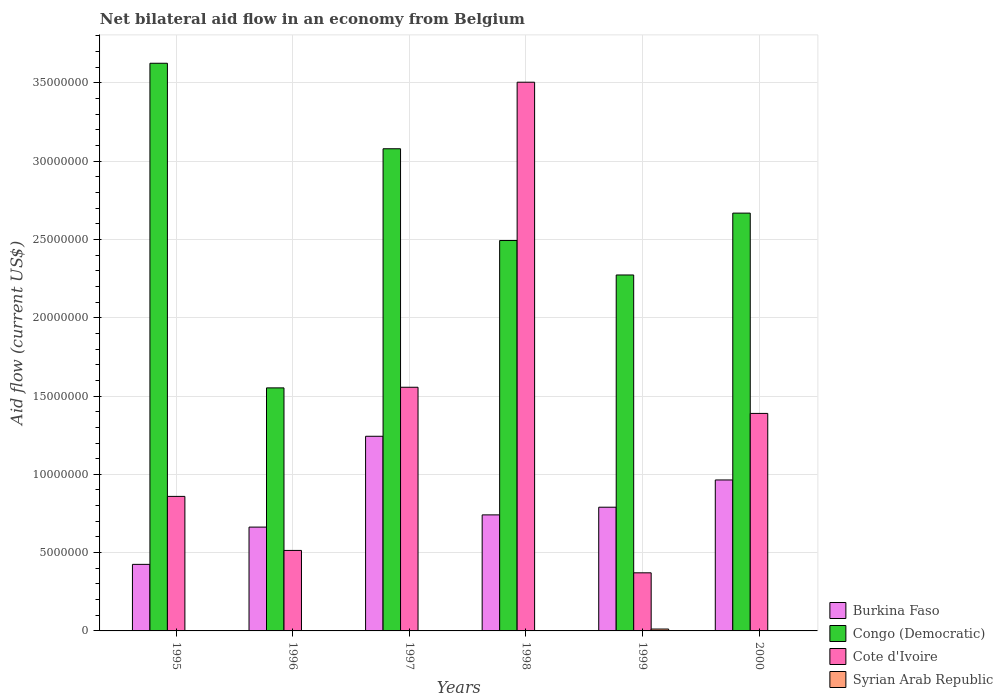How many different coloured bars are there?
Your answer should be compact. 4. How many groups of bars are there?
Provide a succinct answer. 6. Are the number of bars on each tick of the X-axis equal?
Offer a terse response. No. How many bars are there on the 2nd tick from the left?
Provide a succinct answer. 3. How many bars are there on the 1st tick from the right?
Keep it short and to the point. 3. What is the label of the 2nd group of bars from the left?
Keep it short and to the point. 1996. What is the net bilateral aid flow in Congo (Democratic) in 2000?
Provide a short and direct response. 2.67e+07. Across all years, what is the maximum net bilateral aid flow in Burkina Faso?
Give a very brief answer. 1.24e+07. Across all years, what is the minimum net bilateral aid flow in Congo (Democratic)?
Keep it short and to the point. 1.55e+07. What is the difference between the net bilateral aid flow in Burkina Faso in 1997 and that in 1999?
Give a very brief answer. 4.53e+06. What is the difference between the net bilateral aid flow in Burkina Faso in 2000 and the net bilateral aid flow in Syrian Arab Republic in 1997?
Provide a short and direct response. 9.64e+06. What is the average net bilateral aid flow in Syrian Arab Republic per year?
Give a very brief answer. 2.00e+04. In the year 1999, what is the difference between the net bilateral aid flow in Syrian Arab Republic and net bilateral aid flow in Congo (Democratic)?
Your response must be concise. -2.26e+07. What is the ratio of the net bilateral aid flow in Congo (Democratic) in 1996 to that in 1997?
Provide a short and direct response. 0.5. What is the difference between the highest and the second highest net bilateral aid flow in Burkina Faso?
Give a very brief answer. 2.79e+06. What is the difference between the highest and the lowest net bilateral aid flow in Burkina Faso?
Keep it short and to the point. 8.18e+06. In how many years, is the net bilateral aid flow in Burkina Faso greater than the average net bilateral aid flow in Burkina Faso taken over all years?
Your response must be concise. 2. Is it the case that in every year, the sum of the net bilateral aid flow in Burkina Faso and net bilateral aid flow in Congo (Democratic) is greater than the net bilateral aid flow in Syrian Arab Republic?
Ensure brevity in your answer.  Yes. How many bars are there?
Offer a terse response. 19. Are all the bars in the graph horizontal?
Your response must be concise. No. How many years are there in the graph?
Ensure brevity in your answer.  6. What is the difference between two consecutive major ticks on the Y-axis?
Provide a succinct answer. 5.00e+06. How many legend labels are there?
Your response must be concise. 4. How are the legend labels stacked?
Your answer should be very brief. Vertical. What is the title of the graph?
Ensure brevity in your answer.  Net bilateral aid flow in an economy from Belgium. Does "Costa Rica" appear as one of the legend labels in the graph?
Provide a short and direct response. No. What is the label or title of the X-axis?
Ensure brevity in your answer.  Years. What is the label or title of the Y-axis?
Your answer should be very brief. Aid flow (current US$). What is the Aid flow (current US$) in Burkina Faso in 1995?
Offer a terse response. 4.25e+06. What is the Aid flow (current US$) in Congo (Democratic) in 1995?
Your answer should be compact. 3.62e+07. What is the Aid flow (current US$) of Cote d'Ivoire in 1995?
Keep it short and to the point. 8.59e+06. What is the Aid flow (current US$) in Burkina Faso in 1996?
Ensure brevity in your answer.  6.63e+06. What is the Aid flow (current US$) of Congo (Democratic) in 1996?
Your answer should be very brief. 1.55e+07. What is the Aid flow (current US$) of Cote d'Ivoire in 1996?
Ensure brevity in your answer.  5.14e+06. What is the Aid flow (current US$) of Syrian Arab Republic in 1996?
Ensure brevity in your answer.  0. What is the Aid flow (current US$) in Burkina Faso in 1997?
Ensure brevity in your answer.  1.24e+07. What is the Aid flow (current US$) in Congo (Democratic) in 1997?
Your response must be concise. 3.08e+07. What is the Aid flow (current US$) in Cote d'Ivoire in 1997?
Provide a succinct answer. 1.56e+07. What is the Aid flow (current US$) of Burkina Faso in 1998?
Provide a succinct answer. 7.41e+06. What is the Aid flow (current US$) of Congo (Democratic) in 1998?
Give a very brief answer. 2.49e+07. What is the Aid flow (current US$) in Cote d'Ivoire in 1998?
Ensure brevity in your answer.  3.50e+07. What is the Aid flow (current US$) in Burkina Faso in 1999?
Offer a very short reply. 7.90e+06. What is the Aid flow (current US$) of Congo (Democratic) in 1999?
Offer a very short reply. 2.27e+07. What is the Aid flow (current US$) in Cote d'Ivoire in 1999?
Your response must be concise. 3.71e+06. What is the Aid flow (current US$) in Syrian Arab Republic in 1999?
Your answer should be compact. 1.20e+05. What is the Aid flow (current US$) of Burkina Faso in 2000?
Your answer should be compact. 9.64e+06. What is the Aid flow (current US$) in Congo (Democratic) in 2000?
Ensure brevity in your answer.  2.67e+07. What is the Aid flow (current US$) in Cote d'Ivoire in 2000?
Your response must be concise. 1.39e+07. What is the Aid flow (current US$) in Syrian Arab Republic in 2000?
Your response must be concise. 0. Across all years, what is the maximum Aid flow (current US$) in Burkina Faso?
Provide a short and direct response. 1.24e+07. Across all years, what is the maximum Aid flow (current US$) of Congo (Democratic)?
Offer a terse response. 3.62e+07. Across all years, what is the maximum Aid flow (current US$) of Cote d'Ivoire?
Give a very brief answer. 3.50e+07. Across all years, what is the minimum Aid flow (current US$) of Burkina Faso?
Your response must be concise. 4.25e+06. Across all years, what is the minimum Aid flow (current US$) in Congo (Democratic)?
Provide a succinct answer. 1.55e+07. Across all years, what is the minimum Aid flow (current US$) of Cote d'Ivoire?
Keep it short and to the point. 3.71e+06. What is the total Aid flow (current US$) of Burkina Faso in the graph?
Provide a short and direct response. 4.83e+07. What is the total Aid flow (current US$) in Congo (Democratic) in the graph?
Provide a succinct answer. 1.57e+08. What is the total Aid flow (current US$) in Cote d'Ivoire in the graph?
Your answer should be very brief. 8.19e+07. What is the difference between the Aid flow (current US$) in Burkina Faso in 1995 and that in 1996?
Your answer should be very brief. -2.38e+06. What is the difference between the Aid flow (current US$) in Congo (Democratic) in 1995 and that in 1996?
Keep it short and to the point. 2.07e+07. What is the difference between the Aid flow (current US$) in Cote d'Ivoire in 1995 and that in 1996?
Your answer should be compact. 3.45e+06. What is the difference between the Aid flow (current US$) of Burkina Faso in 1995 and that in 1997?
Ensure brevity in your answer.  -8.18e+06. What is the difference between the Aid flow (current US$) in Congo (Democratic) in 1995 and that in 1997?
Provide a succinct answer. 5.46e+06. What is the difference between the Aid flow (current US$) in Cote d'Ivoire in 1995 and that in 1997?
Provide a succinct answer. -6.97e+06. What is the difference between the Aid flow (current US$) in Burkina Faso in 1995 and that in 1998?
Provide a short and direct response. -3.16e+06. What is the difference between the Aid flow (current US$) in Congo (Democratic) in 1995 and that in 1998?
Your response must be concise. 1.13e+07. What is the difference between the Aid flow (current US$) of Cote d'Ivoire in 1995 and that in 1998?
Your answer should be very brief. -2.64e+07. What is the difference between the Aid flow (current US$) in Burkina Faso in 1995 and that in 1999?
Your response must be concise. -3.65e+06. What is the difference between the Aid flow (current US$) in Congo (Democratic) in 1995 and that in 1999?
Your response must be concise. 1.35e+07. What is the difference between the Aid flow (current US$) in Cote d'Ivoire in 1995 and that in 1999?
Ensure brevity in your answer.  4.88e+06. What is the difference between the Aid flow (current US$) of Burkina Faso in 1995 and that in 2000?
Keep it short and to the point. -5.39e+06. What is the difference between the Aid flow (current US$) of Congo (Democratic) in 1995 and that in 2000?
Ensure brevity in your answer.  9.57e+06. What is the difference between the Aid flow (current US$) of Cote d'Ivoire in 1995 and that in 2000?
Make the answer very short. -5.30e+06. What is the difference between the Aid flow (current US$) in Burkina Faso in 1996 and that in 1997?
Offer a very short reply. -5.80e+06. What is the difference between the Aid flow (current US$) of Congo (Democratic) in 1996 and that in 1997?
Ensure brevity in your answer.  -1.53e+07. What is the difference between the Aid flow (current US$) of Cote d'Ivoire in 1996 and that in 1997?
Your answer should be compact. -1.04e+07. What is the difference between the Aid flow (current US$) in Burkina Faso in 1996 and that in 1998?
Offer a very short reply. -7.80e+05. What is the difference between the Aid flow (current US$) of Congo (Democratic) in 1996 and that in 1998?
Make the answer very short. -9.41e+06. What is the difference between the Aid flow (current US$) in Cote d'Ivoire in 1996 and that in 1998?
Your answer should be compact. -2.99e+07. What is the difference between the Aid flow (current US$) in Burkina Faso in 1996 and that in 1999?
Offer a very short reply. -1.27e+06. What is the difference between the Aid flow (current US$) of Congo (Democratic) in 1996 and that in 1999?
Provide a succinct answer. -7.21e+06. What is the difference between the Aid flow (current US$) of Cote d'Ivoire in 1996 and that in 1999?
Offer a terse response. 1.43e+06. What is the difference between the Aid flow (current US$) in Burkina Faso in 1996 and that in 2000?
Keep it short and to the point. -3.01e+06. What is the difference between the Aid flow (current US$) of Congo (Democratic) in 1996 and that in 2000?
Keep it short and to the point. -1.12e+07. What is the difference between the Aid flow (current US$) in Cote d'Ivoire in 1996 and that in 2000?
Offer a very short reply. -8.75e+06. What is the difference between the Aid flow (current US$) of Burkina Faso in 1997 and that in 1998?
Offer a very short reply. 5.02e+06. What is the difference between the Aid flow (current US$) in Congo (Democratic) in 1997 and that in 1998?
Your answer should be very brief. 5.86e+06. What is the difference between the Aid flow (current US$) in Cote d'Ivoire in 1997 and that in 1998?
Make the answer very short. -1.95e+07. What is the difference between the Aid flow (current US$) in Burkina Faso in 1997 and that in 1999?
Provide a succinct answer. 4.53e+06. What is the difference between the Aid flow (current US$) of Congo (Democratic) in 1997 and that in 1999?
Make the answer very short. 8.06e+06. What is the difference between the Aid flow (current US$) in Cote d'Ivoire in 1997 and that in 1999?
Make the answer very short. 1.18e+07. What is the difference between the Aid flow (current US$) of Burkina Faso in 1997 and that in 2000?
Keep it short and to the point. 2.79e+06. What is the difference between the Aid flow (current US$) in Congo (Democratic) in 1997 and that in 2000?
Your answer should be very brief. 4.11e+06. What is the difference between the Aid flow (current US$) in Cote d'Ivoire in 1997 and that in 2000?
Keep it short and to the point. 1.67e+06. What is the difference between the Aid flow (current US$) of Burkina Faso in 1998 and that in 1999?
Offer a very short reply. -4.90e+05. What is the difference between the Aid flow (current US$) of Congo (Democratic) in 1998 and that in 1999?
Offer a terse response. 2.20e+06. What is the difference between the Aid flow (current US$) in Cote d'Ivoire in 1998 and that in 1999?
Your answer should be compact. 3.13e+07. What is the difference between the Aid flow (current US$) in Burkina Faso in 1998 and that in 2000?
Ensure brevity in your answer.  -2.23e+06. What is the difference between the Aid flow (current US$) of Congo (Democratic) in 1998 and that in 2000?
Give a very brief answer. -1.75e+06. What is the difference between the Aid flow (current US$) in Cote d'Ivoire in 1998 and that in 2000?
Provide a succinct answer. 2.12e+07. What is the difference between the Aid flow (current US$) in Burkina Faso in 1999 and that in 2000?
Your response must be concise. -1.74e+06. What is the difference between the Aid flow (current US$) of Congo (Democratic) in 1999 and that in 2000?
Ensure brevity in your answer.  -3.95e+06. What is the difference between the Aid flow (current US$) in Cote d'Ivoire in 1999 and that in 2000?
Ensure brevity in your answer.  -1.02e+07. What is the difference between the Aid flow (current US$) of Burkina Faso in 1995 and the Aid flow (current US$) of Congo (Democratic) in 1996?
Your response must be concise. -1.13e+07. What is the difference between the Aid flow (current US$) of Burkina Faso in 1995 and the Aid flow (current US$) of Cote d'Ivoire in 1996?
Offer a terse response. -8.90e+05. What is the difference between the Aid flow (current US$) in Congo (Democratic) in 1995 and the Aid flow (current US$) in Cote d'Ivoire in 1996?
Make the answer very short. 3.11e+07. What is the difference between the Aid flow (current US$) of Burkina Faso in 1995 and the Aid flow (current US$) of Congo (Democratic) in 1997?
Provide a short and direct response. -2.65e+07. What is the difference between the Aid flow (current US$) of Burkina Faso in 1995 and the Aid flow (current US$) of Cote d'Ivoire in 1997?
Offer a terse response. -1.13e+07. What is the difference between the Aid flow (current US$) in Congo (Democratic) in 1995 and the Aid flow (current US$) in Cote d'Ivoire in 1997?
Offer a terse response. 2.07e+07. What is the difference between the Aid flow (current US$) of Burkina Faso in 1995 and the Aid flow (current US$) of Congo (Democratic) in 1998?
Offer a very short reply. -2.07e+07. What is the difference between the Aid flow (current US$) in Burkina Faso in 1995 and the Aid flow (current US$) in Cote d'Ivoire in 1998?
Keep it short and to the point. -3.08e+07. What is the difference between the Aid flow (current US$) in Congo (Democratic) in 1995 and the Aid flow (current US$) in Cote d'Ivoire in 1998?
Offer a terse response. 1.21e+06. What is the difference between the Aid flow (current US$) in Burkina Faso in 1995 and the Aid flow (current US$) in Congo (Democratic) in 1999?
Make the answer very short. -1.85e+07. What is the difference between the Aid flow (current US$) in Burkina Faso in 1995 and the Aid flow (current US$) in Cote d'Ivoire in 1999?
Provide a succinct answer. 5.40e+05. What is the difference between the Aid flow (current US$) in Burkina Faso in 1995 and the Aid flow (current US$) in Syrian Arab Republic in 1999?
Give a very brief answer. 4.13e+06. What is the difference between the Aid flow (current US$) in Congo (Democratic) in 1995 and the Aid flow (current US$) in Cote d'Ivoire in 1999?
Your answer should be compact. 3.25e+07. What is the difference between the Aid flow (current US$) of Congo (Democratic) in 1995 and the Aid flow (current US$) of Syrian Arab Republic in 1999?
Keep it short and to the point. 3.61e+07. What is the difference between the Aid flow (current US$) in Cote d'Ivoire in 1995 and the Aid flow (current US$) in Syrian Arab Republic in 1999?
Keep it short and to the point. 8.47e+06. What is the difference between the Aid flow (current US$) of Burkina Faso in 1995 and the Aid flow (current US$) of Congo (Democratic) in 2000?
Make the answer very short. -2.24e+07. What is the difference between the Aid flow (current US$) in Burkina Faso in 1995 and the Aid flow (current US$) in Cote d'Ivoire in 2000?
Provide a succinct answer. -9.64e+06. What is the difference between the Aid flow (current US$) in Congo (Democratic) in 1995 and the Aid flow (current US$) in Cote d'Ivoire in 2000?
Provide a short and direct response. 2.24e+07. What is the difference between the Aid flow (current US$) in Burkina Faso in 1996 and the Aid flow (current US$) in Congo (Democratic) in 1997?
Keep it short and to the point. -2.42e+07. What is the difference between the Aid flow (current US$) of Burkina Faso in 1996 and the Aid flow (current US$) of Cote d'Ivoire in 1997?
Ensure brevity in your answer.  -8.93e+06. What is the difference between the Aid flow (current US$) in Burkina Faso in 1996 and the Aid flow (current US$) in Congo (Democratic) in 1998?
Give a very brief answer. -1.83e+07. What is the difference between the Aid flow (current US$) in Burkina Faso in 1996 and the Aid flow (current US$) in Cote d'Ivoire in 1998?
Offer a very short reply. -2.84e+07. What is the difference between the Aid flow (current US$) in Congo (Democratic) in 1996 and the Aid flow (current US$) in Cote d'Ivoire in 1998?
Your answer should be very brief. -1.95e+07. What is the difference between the Aid flow (current US$) in Burkina Faso in 1996 and the Aid flow (current US$) in Congo (Democratic) in 1999?
Offer a terse response. -1.61e+07. What is the difference between the Aid flow (current US$) of Burkina Faso in 1996 and the Aid flow (current US$) of Cote d'Ivoire in 1999?
Provide a succinct answer. 2.92e+06. What is the difference between the Aid flow (current US$) in Burkina Faso in 1996 and the Aid flow (current US$) in Syrian Arab Republic in 1999?
Your answer should be very brief. 6.51e+06. What is the difference between the Aid flow (current US$) in Congo (Democratic) in 1996 and the Aid flow (current US$) in Cote d'Ivoire in 1999?
Your response must be concise. 1.18e+07. What is the difference between the Aid flow (current US$) in Congo (Democratic) in 1996 and the Aid flow (current US$) in Syrian Arab Republic in 1999?
Make the answer very short. 1.54e+07. What is the difference between the Aid flow (current US$) of Cote d'Ivoire in 1996 and the Aid flow (current US$) of Syrian Arab Republic in 1999?
Provide a short and direct response. 5.02e+06. What is the difference between the Aid flow (current US$) in Burkina Faso in 1996 and the Aid flow (current US$) in Congo (Democratic) in 2000?
Your answer should be very brief. -2.00e+07. What is the difference between the Aid flow (current US$) in Burkina Faso in 1996 and the Aid flow (current US$) in Cote d'Ivoire in 2000?
Your answer should be very brief. -7.26e+06. What is the difference between the Aid flow (current US$) of Congo (Democratic) in 1996 and the Aid flow (current US$) of Cote d'Ivoire in 2000?
Give a very brief answer. 1.63e+06. What is the difference between the Aid flow (current US$) in Burkina Faso in 1997 and the Aid flow (current US$) in Congo (Democratic) in 1998?
Your response must be concise. -1.25e+07. What is the difference between the Aid flow (current US$) of Burkina Faso in 1997 and the Aid flow (current US$) of Cote d'Ivoire in 1998?
Your answer should be compact. -2.26e+07. What is the difference between the Aid flow (current US$) of Congo (Democratic) in 1997 and the Aid flow (current US$) of Cote d'Ivoire in 1998?
Keep it short and to the point. -4.25e+06. What is the difference between the Aid flow (current US$) of Burkina Faso in 1997 and the Aid flow (current US$) of Congo (Democratic) in 1999?
Your response must be concise. -1.03e+07. What is the difference between the Aid flow (current US$) in Burkina Faso in 1997 and the Aid flow (current US$) in Cote d'Ivoire in 1999?
Your answer should be compact. 8.72e+06. What is the difference between the Aid flow (current US$) in Burkina Faso in 1997 and the Aid flow (current US$) in Syrian Arab Republic in 1999?
Your answer should be compact. 1.23e+07. What is the difference between the Aid flow (current US$) of Congo (Democratic) in 1997 and the Aid flow (current US$) of Cote d'Ivoire in 1999?
Provide a succinct answer. 2.71e+07. What is the difference between the Aid flow (current US$) in Congo (Democratic) in 1997 and the Aid flow (current US$) in Syrian Arab Republic in 1999?
Give a very brief answer. 3.07e+07. What is the difference between the Aid flow (current US$) in Cote d'Ivoire in 1997 and the Aid flow (current US$) in Syrian Arab Republic in 1999?
Provide a short and direct response. 1.54e+07. What is the difference between the Aid flow (current US$) of Burkina Faso in 1997 and the Aid flow (current US$) of Congo (Democratic) in 2000?
Give a very brief answer. -1.42e+07. What is the difference between the Aid flow (current US$) in Burkina Faso in 1997 and the Aid flow (current US$) in Cote d'Ivoire in 2000?
Offer a terse response. -1.46e+06. What is the difference between the Aid flow (current US$) in Congo (Democratic) in 1997 and the Aid flow (current US$) in Cote d'Ivoire in 2000?
Offer a terse response. 1.69e+07. What is the difference between the Aid flow (current US$) of Burkina Faso in 1998 and the Aid flow (current US$) of Congo (Democratic) in 1999?
Provide a succinct answer. -1.53e+07. What is the difference between the Aid flow (current US$) of Burkina Faso in 1998 and the Aid flow (current US$) of Cote d'Ivoire in 1999?
Your answer should be compact. 3.70e+06. What is the difference between the Aid flow (current US$) of Burkina Faso in 1998 and the Aid flow (current US$) of Syrian Arab Republic in 1999?
Offer a very short reply. 7.29e+06. What is the difference between the Aid flow (current US$) of Congo (Democratic) in 1998 and the Aid flow (current US$) of Cote d'Ivoire in 1999?
Make the answer very short. 2.12e+07. What is the difference between the Aid flow (current US$) in Congo (Democratic) in 1998 and the Aid flow (current US$) in Syrian Arab Republic in 1999?
Make the answer very short. 2.48e+07. What is the difference between the Aid flow (current US$) in Cote d'Ivoire in 1998 and the Aid flow (current US$) in Syrian Arab Republic in 1999?
Make the answer very short. 3.49e+07. What is the difference between the Aid flow (current US$) in Burkina Faso in 1998 and the Aid flow (current US$) in Congo (Democratic) in 2000?
Offer a terse response. -1.93e+07. What is the difference between the Aid flow (current US$) in Burkina Faso in 1998 and the Aid flow (current US$) in Cote d'Ivoire in 2000?
Your response must be concise. -6.48e+06. What is the difference between the Aid flow (current US$) of Congo (Democratic) in 1998 and the Aid flow (current US$) of Cote d'Ivoire in 2000?
Keep it short and to the point. 1.10e+07. What is the difference between the Aid flow (current US$) of Burkina Faso in 1999 and the Aid flow (current US$) of Congo (Democratic) in 2000?
Ensure brevity in your answer.  -1.88e+07. What is the difference between the Aid flow (current US$) in Burkina Faso in 1999 and the Aid flow (current US$) in Cote d'Ivoire in 2000?
Provide a short and direct response. -5.99e+06. What is the difference between the Aid flow (current US$) in Congo (Democratic) in 1999 and the Aid flow (current US$) in Cote d'Ivoire in 2000?
Provide a short and direct response. 8.84e+06. What is the average Aid flow (current US$) of Burkina Faso per year?
Provide a short and direct response. 8.04e+06. What is the average Aid flow (current US$) of Congo (Democratic) per year?
Keep it short and to the point. 2.62e+07. What is the average Aid flow (current US$) in Cote d'Ivoire per year?
Your response must be concise. 1.37e+07. What is the average Aid flow (current US$) of Syrian Arab Republic per year?
Offer a terse response. 2.00e+04. In the year 1995, what is the difference between the Aid flow (current US$) of Burkina Faso and Aid flow (current US$) of Congo (Democratic)?
Keep it short and to the point. -3.20e+07. In the year 1995, what is the difference between the Aid flow (current US$) of Burkina Faso and Aid flow (current US$) of Cote d'Ivoire?
Your answer should be very brief. -4.34e+06. In the year 1995, what is the difference between the Aid flow (current US$) in Congo (Democratic) and Aid flow (current US$) in Cote d'Ivoire?
Your answer should be compact. 2.77e+07. In the year 1996, what is the difference between the Aid flow (current US$) in Burkina Faso and Aid flow (current US$) in Congo (Democratic)?
Provide a succinct answer. -8.89e+06. In the year 1996, what is the difference between the Aid flow (current US$) of Burkina Faso and Aid flow (current US$) of Cote d'Ivoire?
Give a very brief answer. 1.49e+06. In the year 1996, what is the difference between the Aid flow (current US$) in Congo (Democratic) and Aid flow (current US$) in Cote d'Ivoire?
Your answer should be compact. 1.04e+07. In the year 1997, what is the difference between the Aid flow (current US$) of Burkina Faso and Aid flow (current US$) of Congo (Democratic)?
Your response must be concise. -1.84e+07. In the year 1997, what is the difference between the Aid flow (current US$) of Burkina Faso and Aid flow (current US$) of Cote d'Ivoire?
Give a very brief answer. -3.13e+06. In the year 1997, what is the difference between the Aid flow (current US$) of Congo (Democratic) and Aid flow (current US$) of Cote d'Ivoire?
Make the answer very short. 1.52e+07. In the year 1998, what is the difference between the Aid flow (current US$) in Burkina Faso and Aid flow (current US$) in Congo (Democratic)?
Offer a terse response. -1.75e+07. In the year 1998, what is the difference between the Aid flow (current US$) in Burkina Faso and Aid flow (current US$) in Cote d'Ivoire?
Your response must be concise. -2.76e+07. In the year 1998, what is the difference between the Aid flow (current US$) of Congo (Democratic) and Aid flow (current US$) of Cote d'Ivoire?
Ensure brevity in your answer.  -1.01e+07. In the year 1999, what is the difference between the Aid flow (current US$) of Burkina Faso and Aid flow (current US$) of Congo (Democratic)?
Provide a succinct answer. -1.48e+07. In the year 1999, what is the difference between the Aid flow (current US$) of Burkina Faso and Aid flow (current US$) of Cote d'Ivoire?
Make the answer very short. 4.19e+06. In the year 1999, what is the difference between the Aid flow (current US$) of Burkina Faso and Aid flow (current US$) of Syrian Arab Republic?
Make the answer very short. 7.78e+06. In the year 1999, what is the difference between the Aid flow (current US$) of Congo (Democratic) and Aid flow (current US$) of Cote d'Ivoire?
Ensure brevity in your answer.  1.90e+07. In the year 1999, what is the difference between the Aid flow (current US$) in Congo (Democratic) and Aid flow (current US$) in Syrian Arab Republic?
Offer a terse response. 2.26e+07. In the year 1999, what is the difference between the Aid flow (current US$) in Cote d'Ivoire and Aid flow (current US$) in Syrian Arab Republic?
Provide a short and direct response. 3.59e+06. In the year 2000, what is the difference between the Aid flow (current US$) in Burkina Faso and Aid flow (current US$) in Congo (Democratic)?
Your answer should be compact. -1.70e+07. In the year 2000, what is the difference between the Aid flow (current US$) in Burkina Faso and Aid flow (current US$) in Cote d'Ivoire?
Ensure brevity in your answer.  -4.25e+06. In the year 2000, what is the difference between the Aid flow (current US$) in Congo (Democratic) and Aid flow (current US$) in Cote d'Ivoire?
Make the answer very short. 1.28e+07. What is the ratio of the Aid flow (current US$) of Burkina Faso in 1995 to that in 1996?
Ensure brevity in your answer.  0.64. What is the ratio of the Aid flow (current US$) of Congo (Democratic) in 1995 to that in 1996?
Your answer should be compact. 2.34. What is the ratio of the Aid flow (current US$) in Cote d'Ivoire in 1995 to that in 1996?
Give a very brief answer. 1.67. What is the ratio of the Aid flow (current US$) in Burkina Faso in 1995 to that in 1997?
Offer a terse response. 0.34. What is the ratio of the Aid flow (current US$) of Congo (Democratic) in 1995 to that in 1997?
Keep it short and to the point. 1.18. What is the ratio of the Aid flow (current US$) of Cote d'Ivoire in 1995 to that in 1997?
Make the answer very short. 0.55. What is the ratio of the Aid flow (current US$) of Burkina Faso in 1995 to that in 1998?
Make the answer very short. 0.57. What is the ratio of the Aid flow (current US$) of Congo (Democratic) in 1995 to that in 1998?
Provide a short and direct response. 1.45. What is the ratio of the Aid flow (current US$) of Cote d'Ivoire in 1995 to that in 1998?
Offer a very short reply. 0.25. What is the ratio of the Aid flow (current US$) of Burkina Faso in 1995 to that in 1999?
Offer a terse response. 0.54. What is the ratio of the Aid flow (current US$) of Congo (Democratic) in 1995 to that in 1999?
Make the answer very short. 1.59. What is the ratio of the Aid flow (current US$) in Cote d'Ivoire in 1995 to that in 1999?
Offer a terse response. 2.32. What is the ratio of the Aid flow (current US$) in Burkina Faso in 1995 to that in 2000?
Your answer should be compact. 0.44. What is the ratio of the Aid flow (current US$) of Congo (Democratic) in 1995 to that in 2000?
Offer a very short reply. 1.36. What is the ratio of the Aid flow (current US$) of Cote d'Ivoire in 1995 to that in 2000?
Ensure brevity in your answer.  0.62. What is the ratio of the Aid flow (current US$) of Burkina Faso in 1996 to that in 1997?
Your answer should be compact. 0.53. What is the ratio of the Aid flow (current US$) in Congo (Democratic) in 1996 to that in 1997?
Make the answer very short. 0.5. What is the ratio of the Aid flow (current US$) in Cote d'Ivoire in 1996 to that in 1997?
Keep it short and to the point. 0.33. What is the ratio of the Aid flow (current US$) in Burkina Faso in 1996 to that in 1998?
Provide a succinct answer. 0.89. What is the ratio of the Aid flow (current US$) in Congo (Democratic) in 1996 to that in 1998?
Keep it short and to the point. 0.62. What is the ratio of the Aid flow (current US$) in Cote d'Ivoire in 1996 to that in 1998?
Provide a succinct answer. 0.15. What is the ratio of the Aid flow (current US$) of Burkina Faso in 1996 to that in 1999?
Provide a succinct answer. 0.84. What is the ratio of the Aid flow (current US$) in Congo (Democratic) in 1996 to that in 1999?
Ensure brevity in your answer.  0.68. What is the ratio of the Aid flow (current US$) of Cote d'Ivoire in 1996 to that in 1999?
Make the answer very short. 1.39. What is the ratio of the Aid flow (current US$) in Burkina Faso in 1996 to that in 2000?
Your response must be concise. 0.69. What is the ratio of the Aid flow (current US$) of Congo (Democratic) in 1996 to that in 2000?
Your answer should be compact. 0.58. What is the ratio of the Aid flow (current US$) in Cote d'Ivoire in 1996 to that in 2000?
Provide a short and direct response. 0.37. What is the ratio of the Aid flow (current US$) of Burkina Faso in 1997 to that in 1998?
Provide a succinct answer. 1.68. What is the ratio of the Aid flow (current US$) of Congo (Democratic) in 1997 to that in 1998?
Give a very brief answer. 1.24. What is the ratio of the Aid flow (current US$) of Cote d'Ivoire in 1997 to that in 1998?
Make the answer very short. 0.44. What is the ratio of the Aid flow (current US$) of Burkina Faso in 1997 to that in 1999?
Give a very brief answer. 1.57. What is the ratio of the Aid flow (current US$) of Congo (Democratic) in 1997 to that in 1999?
Keep it short and to the point. 1.35. What is the ratio of the Aid flow (current US$) in Cote d'Ivoire in 1997 to that in 1999?
Provide a succinct answer. 4.19. What is the ratio of the Aid flow (current US$) in Burkina Faso in 1997 to that in 2000?
Give a very brief answer. 1.29. What is the ratio of the Aid flow (current US$) in Congo (Democratic) in 1997 to that in 2000?
Make the answer very short. 1.15. What is the ratio of the Aid flow (current US$) in Cote d'Ivoire in 1997 to that in 2000?
Offer a terse response. 1.12. What is the ratio of the Aid flow (current US$) in Burkina Faso in 1998 to that in 1999?
Make the answer very short. 0.94. What is the ratio of the Aid flow (current US$) of Congo (Democratic) in 1998 to that in 1999?
Make the answer very short. 1.1. What is the ratio of the Aid flow (current US$) of Cote d'Ivoire in 1998 to that in 1999?
Ensure brevity in your answer.  9.44. What is the ratio of the Aid flow (current US$) in Burkina Faso in 1998 to that in 2000?
Offer a terse response. 0.77. What is the ratio of the Aid flow (current US$) of Congo (Democratic) in 1998 to that in 2000?
Provide a succinct answer. 0.93. What is the ratio of the Aid flow (current US$) of Cote d'Ivoire in 1998 to that in 2000?
Provide a short and direct response. 2.52. What is the ratio of the Aid flow (current US$) in Burkina Faso in 1999 to that in 2000?
Your response must be concise. 0.82. What is the ratio of the Aid flow (current US$) of Congo (Democratic) in 1999 to that in 2000?
Your answer should be very brief. 0.85. What is the ratio of the Aid flow (current US$) in Cote d'Ivoire in 1999 to that in 2000?
Provide a succinct answer. 0.27. What is the difference between the highest and the second highest Aid flow (current US$) of Burkina Faso?
Provide a short and direct response. 2.79e+06. What is the difference between the highest and the second highest Aid flow (current US$) of Congo (Democratic)?
Your response must be concise. 5.46e+06. What is the difference between the highest and the second highest Aid flow (current US$) of Cote d'Ivoire?
Make the answer very short. 1.95e+07. What is the difference between the highest and the lowest Aid flow (current US$) in Burkina Faso?
Give a very brief answer. 8.18e+06. What is the difference between the highest and the lowest Aid flow (current US$) of Congo (Democratic)?
Offer a terse response. 2.07e+07. What is the difference between the highest and the lowest Aid flow (current US$) of Cote d'Ivoire?
Keep it short and to the point. 3.13e+07. What is the difference between the highest and the lowest Aid flow (current US$) in Syrian Arab Republic?
Provide a succinct answer. 1.20e+05. 